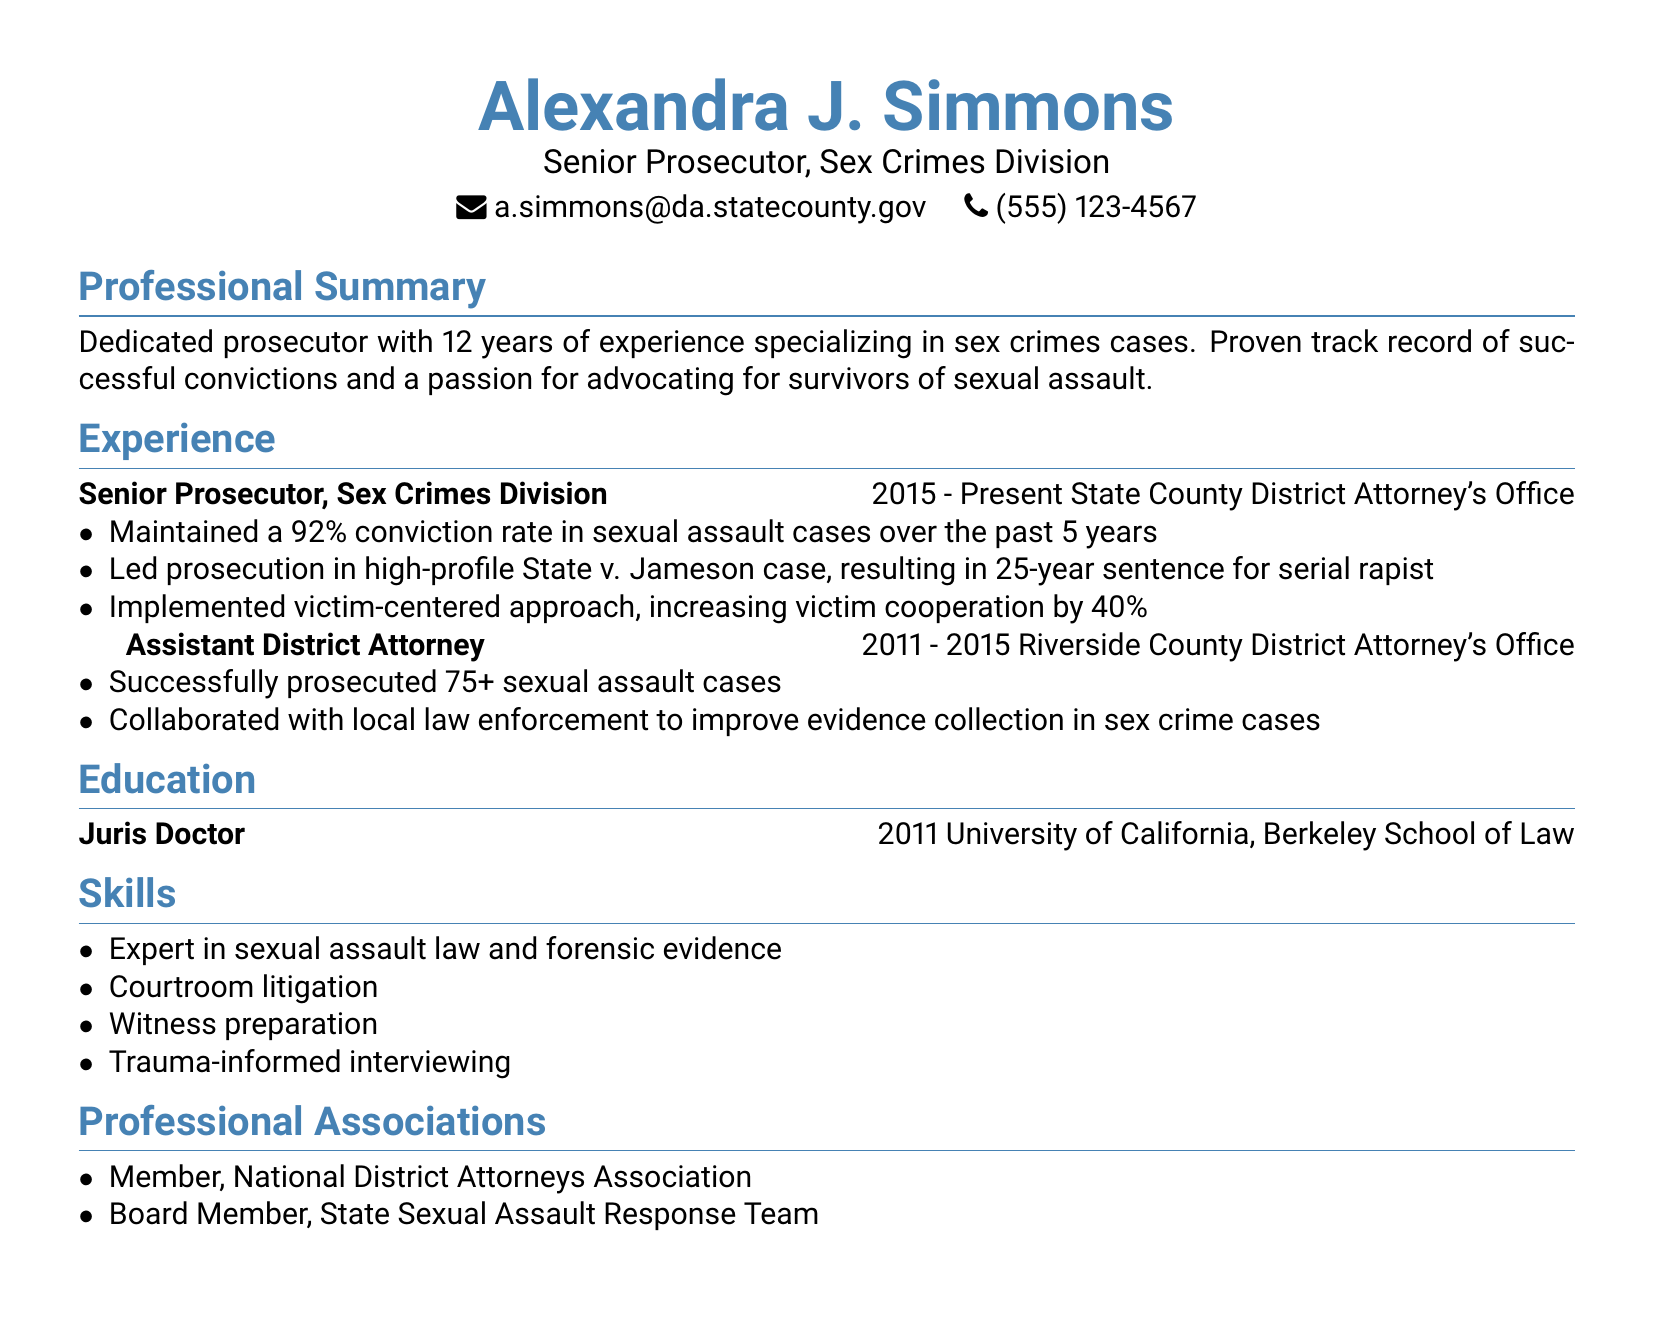What is the name of the Senior Prosecutor? The name listed in the document is Alexandra J. Simmons.
Answer: Alexandra J. Simmons What is the conviction rate maintained by Alexandra over the past 5 years? The document states that she has maintained a 92% conviction rate in sexual assault cases during that period.
Answer: 92% Which case did Alexandra lead that resulted in a 25-year sentence? The document mentions the high-profile case State v. Jameson, which resulted in a 25-year sentence for a serial rapist.
Answer: State v. Jameson How many sexual assault cases did she successfully prosecute as an Assistant District Attorney? The document cites that she successfully prosecuted over 75 sexual assault cases in her previous position.
Answer: 75+ What kind of approach did Alexandra implement to increase victim cooperation? The document highlights that she implemented a victim-centered approach, which increased victim cooperation by 40%.
Answer: Victim-centered approach In which year did Alexandra receive her Juris Doctor degree? According to the document, she earned her Juris Doctor degree in 2011.
Answer: 2011 Which professional association is she a board member of? The document lists her as a board member of the State Sexual Assault Response Team.
Answer: State Sexual Assault Response Team What is one of the main skills listed in Alexandra's resume? The document includes "Expert in sexual assault law and forensic evidence" as one of her main skills.
Answer: Expert in sexual assault law and forensic evidence How long has Alexandra been working as a prosecutor? The document indicates she has 12 years of experience specializing in sex crimes cases.
Answer: 12 years 